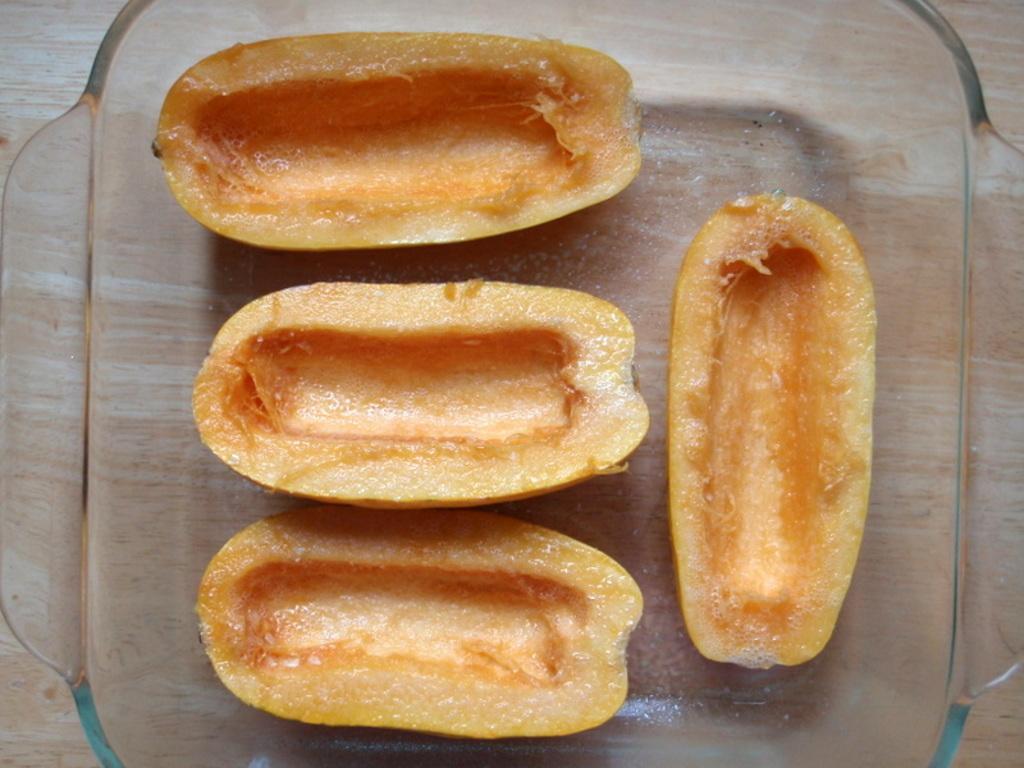How would you summarize this image in a sentence or two? In the middle of the image there is a table, on the table there is a bowl. In the bowl there are some fruits. 